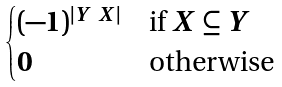<formula> <loc_0><loc_0><loc_500><loc_500>\begin{cases} ( - 1 ) ^ { | Y \ X | } & \text {if $X\subseteq Y$} \\ 0 & \text {otherwise} \end{cases}</formula> 